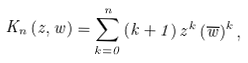Convert formula to latex. <formula><loc_0><loc_0><loc_500><loc_500>K _ { n } \left ( z , w \right ) = \sum _ { k = 0 } ^ { n } \left ( k + 1 \right ) z ^ { k } \left ( \overline { w } \right ) ^ { k } ,</formula> 